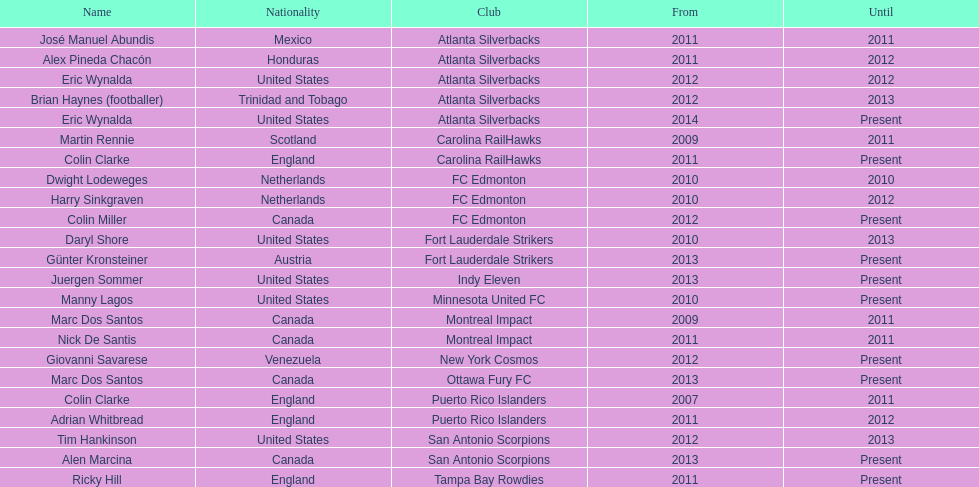Who was the coach of fc edmonton before miller? Harry Sinkgraven. 